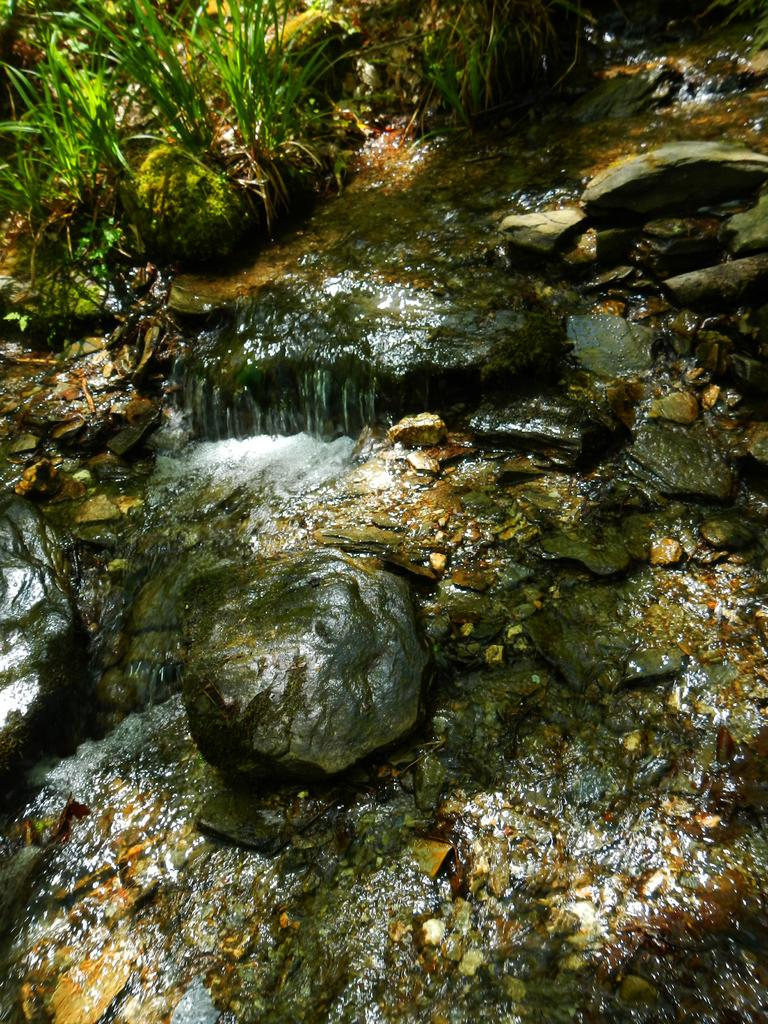What type of natural elements can be seen in the image? There are rocks and water in the image. Where are the plants located in the image? The plants are on the top left side of the image. What type of stove can be seen in the image? There is no stove present in the image. What type of attraction is depicted in the image? The image does not depict any specific attraction; it features rocks, water, and plants. 